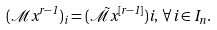<formula> <loc_0><loc_0><loc_500><loc_500>( \mathcal { M } x ^ { r - 1 } ) _ { i } = ( \tilde { \mathcal { M } } x ^ { [ r - 1 ] } ) i , \, \forall \, i \in I _ { n } .</formula> 